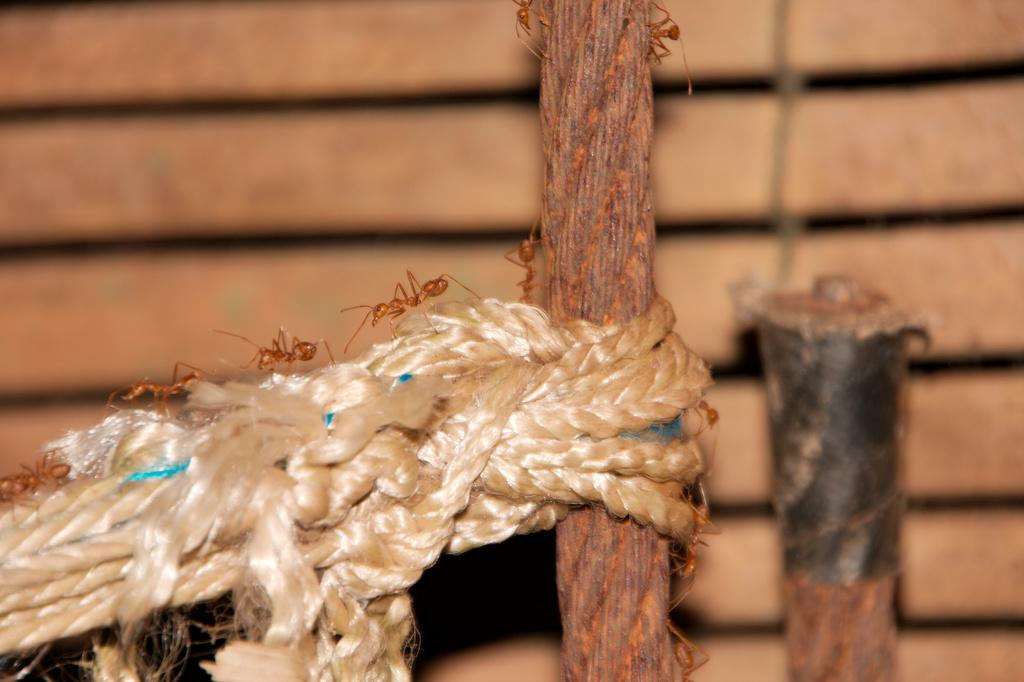What objects are present in the picture? There are ropes in the picture. What are the ants doing in the picture? The ants are walking on the ropes. Can you describe the background of the picture? The background image is blurry. What news is being reported by the ants in the picture? There is no news being reported in the picture, as it only features ants walking on ropes and a blurry background. 